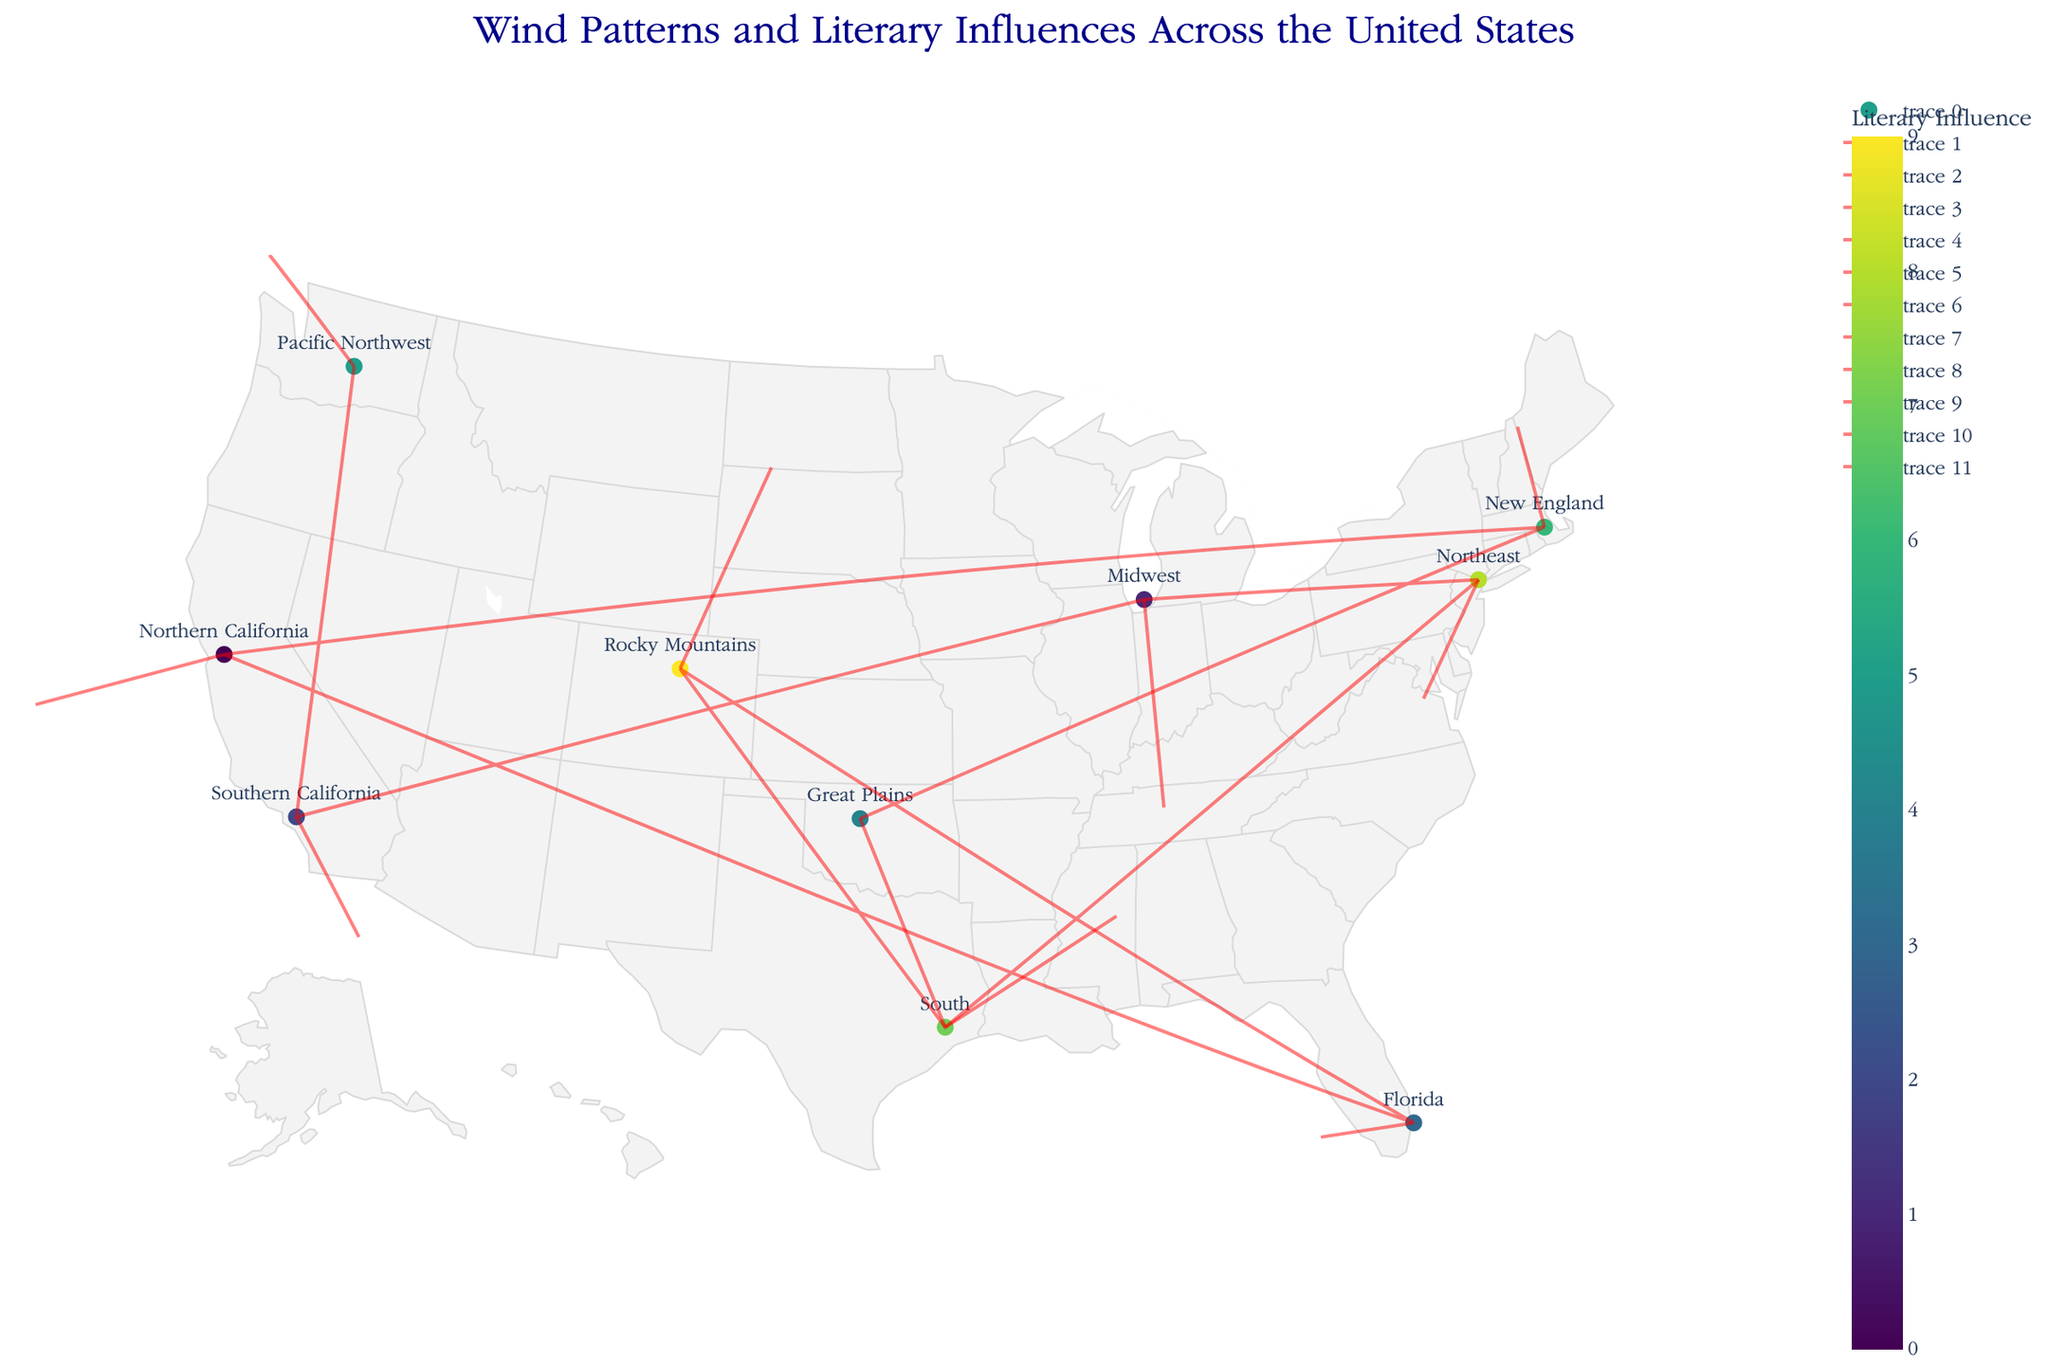What's the title of the figure? The title of the figure is usually located at the top center or top of the plot area. In this case, the title is specified in the `update_layout` part of the code.
Answer: Wind Patterns and Literary Influences Across the United States How many regions are represented in the plot? By counting the unique points (markers) on the plot, each representing a different region, we can determine the number of regions. The dataset indicates there are 10 regions.
Answer: 10 Which region is associated with 'Hollywood Screenplays' influence? Checking the hover text for the markers or referring to the dataset, the region associated with 'Hollywood Screenplays' is located at coordinates (-118, 34). This corresponds to Southern California.
Answer: Southern California What literary influence is represented by the marker with the highest y-coordinate (latitude)? The marker with the highest y-coordinate is located at (47, -120), and the literary influence mentioned in the corresponding hover text is 'Nature Writing'.
Answer: Nature Writing What are the coordinates for the endpoint of the vector originating at the Great Plains region? First, locate the Great Plains region at coordinates (-98, 36). The quiver plot shows the direction and magnitude of the vector (u=1, v=-2). Using the scale of 3, the endpoint coordinates are -98 + (3*1), 36 + (3*-2) which calculates to (-95, 30).
Answer: (-95, 30) Which region experiences a wind pattern moving southwards? A wind pattern moving southwards would have a negative v component. The regions with a negative v component are Southern California (-118, 34), Midwest (-87, 42), and Great Plains (-98, 36).
Answer: Southern California, Midwest, Great Plains Does the Rocky Mountains region experience a stronger wind influence compared to New England based on vector lengths? To determine this, we compare the magnitudes of the vectors. Rocky Mountains has vector (1,2), and New England has vector (0,1). The magnitude (length) is calculated using sqrt(u^2 + v^2). For Rocky Mountains: sqrt(1^2 + 2^2) = sqrt(5). For New England: sqrt(0^2 + 1^2) = 1. Since sqrt(5) is greater than 1, the Rocky Mountains experience a stronger wind.
Answer: Yes Compare the directions of the wind vectors in Northern California and Florida. Do they have the same direction? Examining the vector components: Northern California has (u=-2, v=-1), and Florida has (u=-1, v=0). The angles (directions) of the vectors differ. Northern California's vector points southwest, whereas Florida's vector points strictly west.
Answer: No Which literary influence is the most centrally located geographically among the regions? The central location can be approximated by visually identifying the central region in the plot. The Midwest, located at approximately (42, -87), is the most central. The corresponding literary influence is 'Heartland Realism'.
Answer: Heartland Realism 